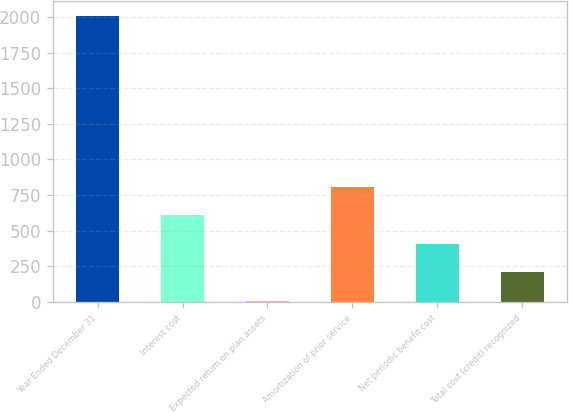<chart> <loc_0><loc_0><loc_500><loc_500><bar_chart><fcel>Year Ended December 31<fcel>Interest cost<fcel>Expected return on plan assets<fcel>Amortization of prior service<fcel>Net periodic benefit cost<fcel>Total cost (credit) recognized<nl><fcel>2009<fcel>608.3<fcel>8<fcel>808.4<fcel>408.2<fcel>208.1<nl></chart> 